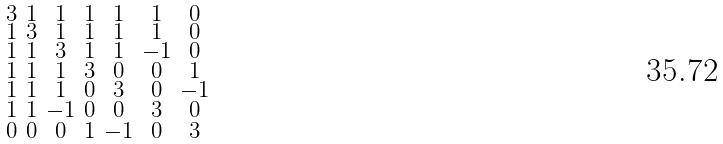Convert formula to latex. <formula><loc_0><loc_0><loc_500><loc_500>\begin{smallmatrix} 3 & 1 & 1 & 1 & 1 & 1 & 0 \\ 1 & 3 & 1 & 1 & 1 & 1 & 0 \\ 1 & 1 & 3 & 1 & 1 & - 1 & 0 \\ 1 & 1 & 1 & 3 & 0 & 0 & 1 \\ 1 & 1 & 1 & 0 & 3 & 0 & - 1 \\ 1 & 1 & - 1 & 0 & 0 & 3 & 0 \\ 0 & 0 & 0 & 1 & - 1 & 0 & 3 \end{smallmatrix}</formula> 